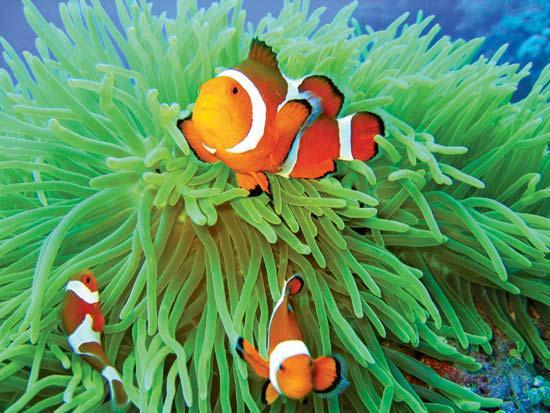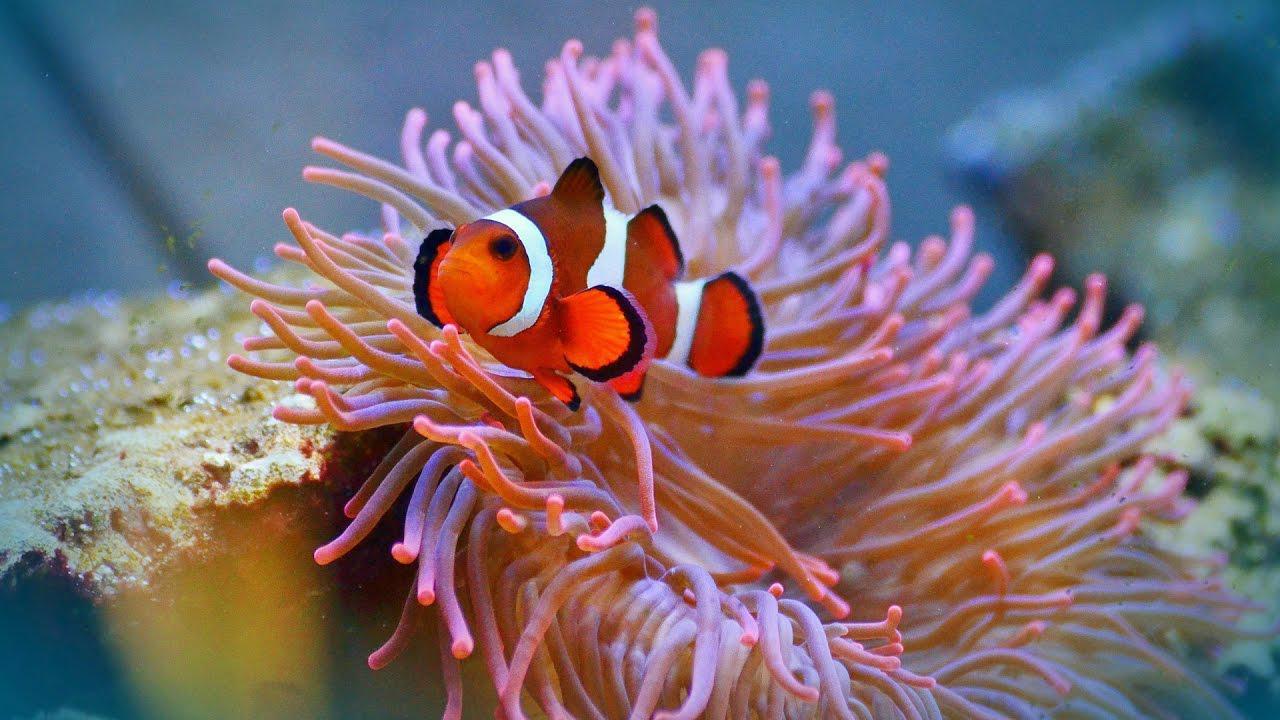The first image is the image on the left, the second image is the image on the right. Analyze the images presented: Is the assertion "In at least one image there is a single orange and white cloud fish swimming above a single coral." valid? Answer yes or no. Yes. The first image is the image on the left, the second image is the image on the right. Analyze the images presented: Is the assertion "One image feature a clown fish next to a sea anemone" valid? Answer yes or no. Yes. 